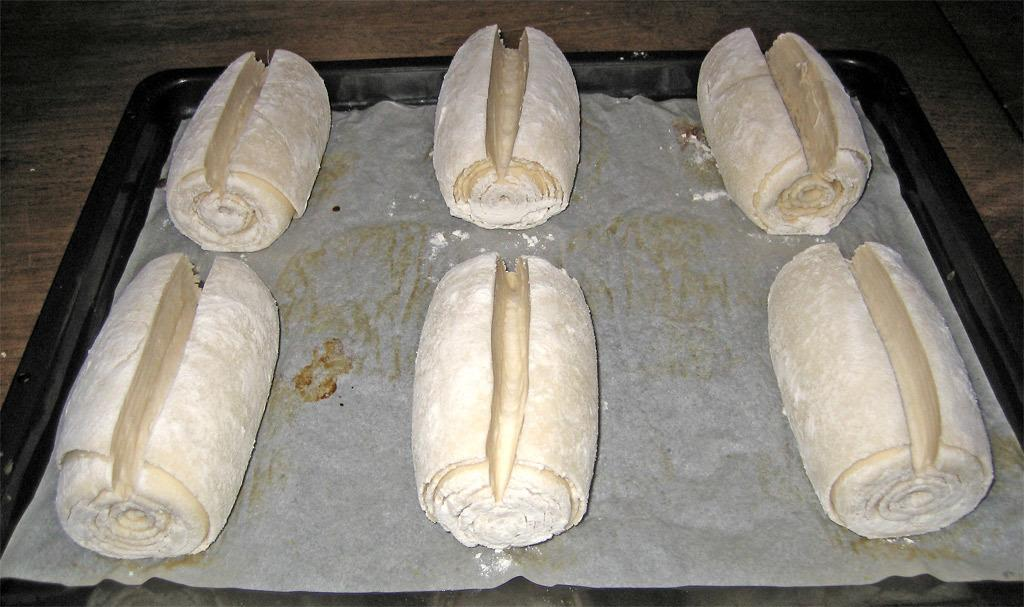What is placed on the tray in the image? There is food placed on a tray in the image. On what surface is the tray resting? The tray is placed on a wooden table. What language is spoken by the cushion in the image? There is no cushion present in the image, and therefore no language can be spoken by it. 